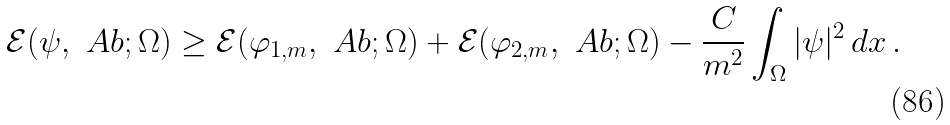Convert formula to latex. <formula><loc_0><loc_0><loc_500><loc_500>\mathcal { E } ( \psi , \ A b ; \Omega ) \geq \mathcal { E } ( \varphi _ { 1 , m } , \ A b ; \Omega ) + \mathcal { E } ( \varphi _ { 2 , m } , \ A b ; \Omega ) - \frac { C } { m ^ { 2 } } \int _ { \Omega } | \psi | ^ { 2 } \, d x \, .</formula> 